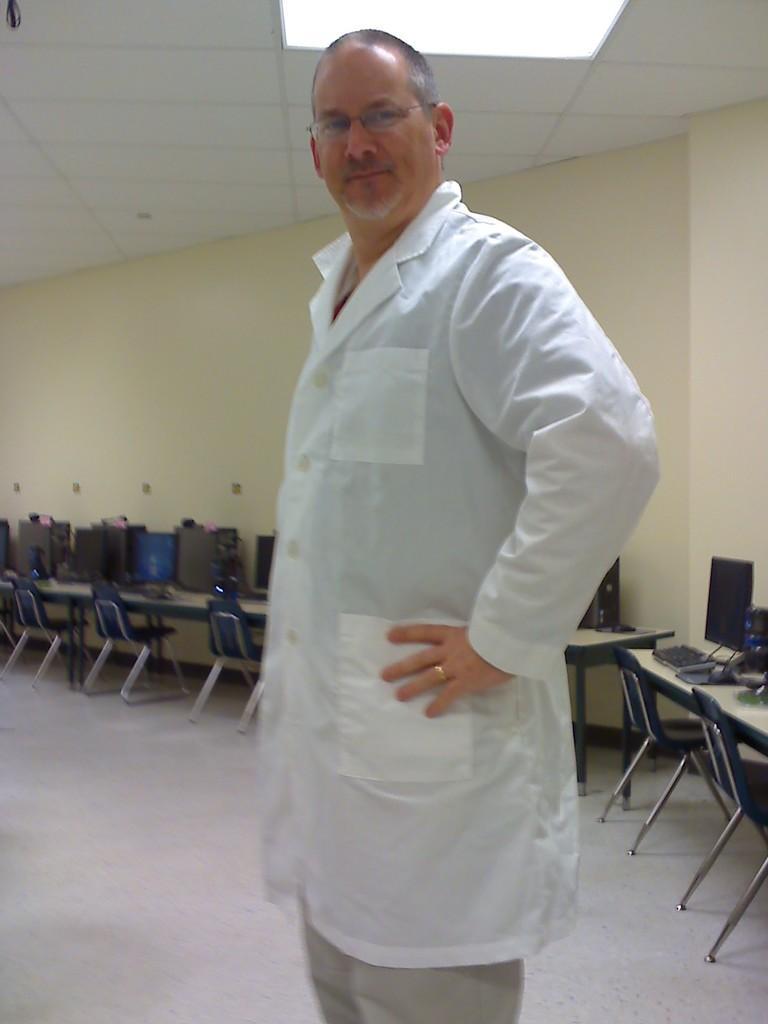In one or two sentences, can you explain what this image depicts? On the background we can see wall in cream colour. This is a ceiling. Here we can see chairs in front of a table and on the table we can see computers and keyboards. Here we can see a man standing in front of a picture wearing a white colour apron. He wore spectacles. 